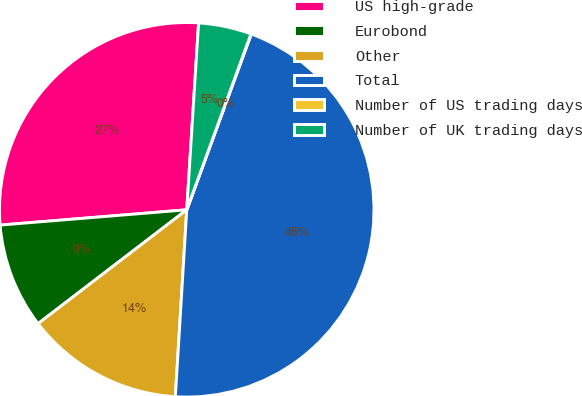Convert chart. <chart><loc_0><loc_0><loc_500><loc_500><pie_chart><fcel>US high-grade<fcel>Eurobond<fcel>Other<fcel>Total<fcel>Number of US trading days<fcel>Number of UK trading days<nl><fcel>27.31%<fcel>9.1%<fcel>13.63%<fcel>45.37%<fcel>0.03%<fcel>4.56%<nl></chart> 